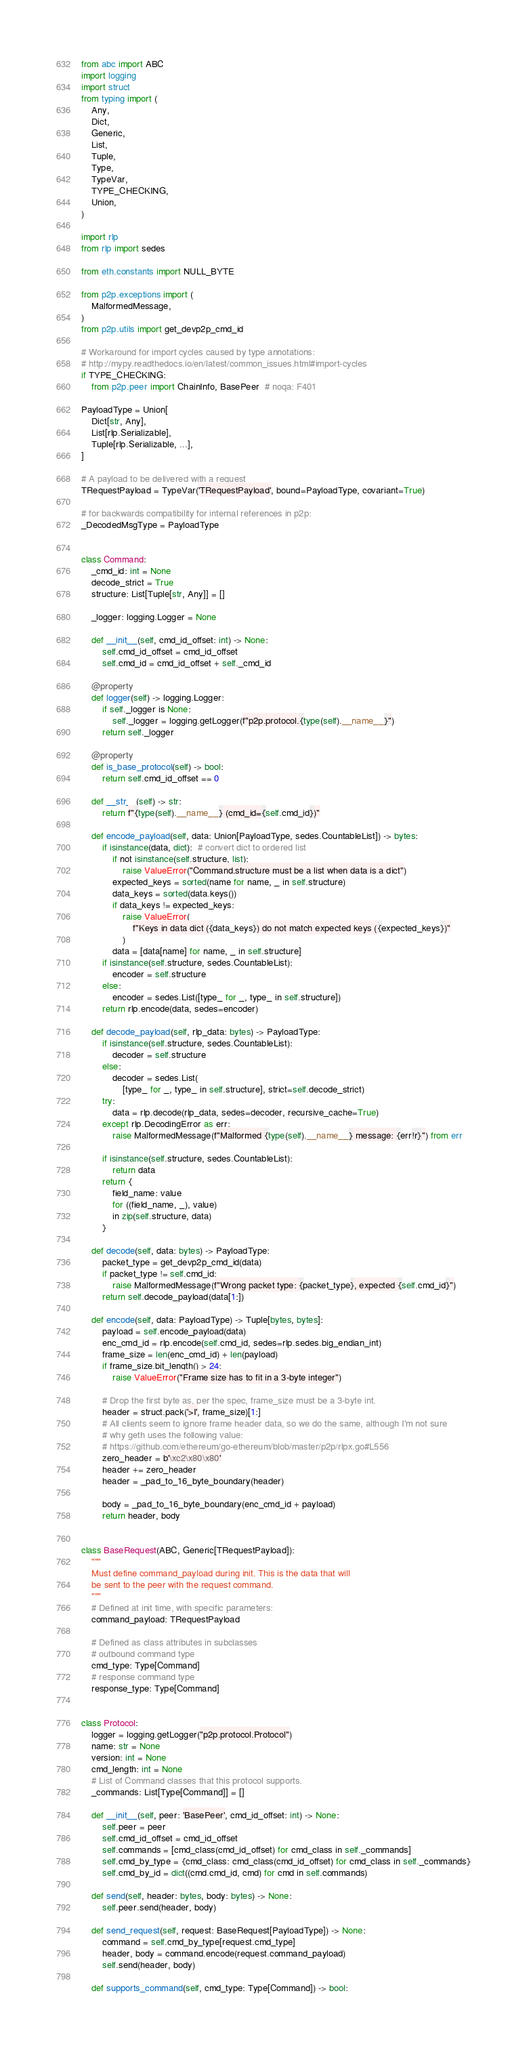Convert code to text. <code><loc_0><loc_0><loc_500><loc_500><_Python_>from abc import ABC
import logging
import struct
from typing import (
    Any,
    Dict,
    Generic,
    List,
    Tuple,
    Type,
    TypeVar,
    TYPE_CHECKING,
    Union,
)

import rlp
from rlp import sedes

from eth.constants import NULL_BYTE

from p2p.exceptions import (
    MalformedMessage,
)
from p2p.utils import get_devp2p_cmd_id

# Workaround for import cycles caused by type annotations:
# http://mypy.readthedocs.io/en/latest/common_issues.html#import-cycles
if TYPE_CHECKING:
    from p2p.peer import ChainInfo, BasePeer  # noqa: F401

PayloadType = Union[
    Dict[str, Any],
    List[rlp.Serializable],
    Tuple[rlp.Serializable, ...],
]

# A payload to be delivered with a request
TRequestPayload = TypeVar('TRequestPayload', bound=PayloadType, covariant=True)

# for backwards compatibility for internal references in p2p:
_DecodedMsgType = PayloadType


class Command:
    _cmd_id: int = None
    decode_strict = True
    structure: List[Tuple[str, Any]] = []

    _logger: logging.Logger = None

    def __init__(self, cmd_id_offset: int) -> None:
        self.cmd_id_offset = cmd_id_offset
        self.cmd_id = cmd_id_offset + self._cmd_id

    @property
    def logger(self) -> logging.Logger:
        if self._logger is None:
            self._logger = logging.getLogger(f"p2p.protocol.{type(self).__name__}")
        return self._logger

    @property
    def is_base_protocol(self) -> bool:
        return self.cmd_id_offset == 0

    def __str__(self) -> str:
        return f"{type(self).__name__} (cmd_id={self.cmd_id})"

    def encode_payload(self, data: Union[PayloadType, sedes.CountableList]) -> bytes:
        if isinstance(data, dict):  # convert dict to ordered list
            if not isinstance(self.structure, list):
                raise ValueError("Command.structure must be a list when data is a dict")
            expected_keys = sorted(name for name, _ in self.structure)
            data_keys = sorted(data.keys())
            if data_keys != expected_keys:
                raise ValueError(
                    f"Keys in data dict ({data_keys}) do not match expected keys ({expected_keys})"
                )
            data = [data[name] for name, _ in self.structure]
        if isinstance(self.structure, sedes.CountableList):
            encoder = self.structure
        else:
            encoder = sedes.List([type_ for _, type_ in self.structure])
        return rlp.encode(data, sedes=encoder)

    def decode_payload(self, rlp_data: bytes) -> PayloadType:
        if isinstance(self.structure, sedes.CountableList):
            decoder = self.structure
        else:
            decoder = sedes.List(
                [type_ for _, type_ in self.structure], strict=self.decode_strict)
        try:
            data = rlp.decode(rlp_data, sedes=decoder, recursive_cache=True)
        except rlp.DecodingError as err:
            raise MalformedMessage(f"Malformed {type(self).__name__} message: {err!r}") from err

        if isinstance(self.structure, sedes.CountableList):
            return data
        return {
            field_name: value
            for ((field_name, _), value)
            in zip(self.structure, data)
        }

    def decode(self, data: bytes) -> PayloadType:
        packet_type = get_devp2p_cmd_id(data)
        if packet_type != self.cmd_id:
            raise MalformedMessage(f"Wrong packet type: {packet_type}, expected {self.cmd_id}")
        return self.decode_payload(data[1:])

    def encode(self, data: PayloadType) -> Tuple[bytes, bytes]:
        payload = self.encode_payload(data)
        enc_cmd_id = rlp.encode(self.cmd_id, sedes=rlp.sedes.big_endian_int)
        frame_size = len(enc_cmd_id) + len(payload)
        if frame_size.bit_length() > 24:
            raise ValueError("Frame size has to fit in a 3-byte integer")

        # Drop the first byte as, per the spec, frame_size must be a 3-byte int.
        header = struct.pack('>I', frame_size)[1:]
        # All clients seem to ignore frame header data, so we do the same, although I'm not sure
        # why geth uses the following value:
        # https://github.com/ethereum/go-ethereum/blob/master/p2p/rlpx.go#L556
        zero_header = b'\xc2\x80\x80'
        header += zero_header
        header = _pad_to_16_byte_boundary(header)

        body = _pad_to_16_byte_boundary(enc_cmd_id + payload)
        return header, body


class BaseRequest(ABC, Generic[TRequestPayload]):
    """
    Must define command_payload during init. This is the data that will
    be sent to the peer with the request command.
    """
    # Defined at init time, with specific parameters:
    command_payload: TRequestPayload

    # Defined as class attributes in subclasses
    # outbound command type
    cmd_type: Type[Command]
    # response command type
    response_type: Type[Command]


class Protocol:
    logger = logging.getLogger("p2p.protocol.Protocol")
    name: str = None
    version: int = None
    cmd_length: int = None
    # List of Command classes that this protocol supports.
    _commands: List[Type[Command]] = []

    def __init__(self, peer: 'BasePeer', cmd_id_offset: int) -> None:
        self.peer = peer
        self.cmd_id_offset = cmd_id_offset
        self.commands = [cmd_class(cmd_id_offset) for cmd_class in self._commands]
        self.cmd_by_type = {cmd_class: cmd_class(cmd_id_offset) for cmd_class in self._commands}
        self.cmd_by_id = dict((cmd.cmd_id, cmd) for cmd in self.commands)

    def send(self, header: bytes, body: bytes) -> None:
        self.peer.send(header, body)

    def send_request(self, request: BaseRequest[PayloadType]) -> None:
        command = self.cmd_by_type[request.cmd_type]
        header, body = command.encode(request.command_payload)
        self.send(header, body)

    def supports_command(self, cmd_type: Type[Command]) -> bool:</code> 